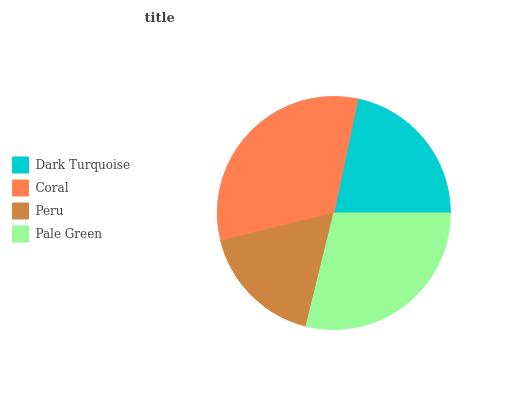Is Peru the minimum?
Answer yes or no. Yes. Is Coral the maximum?
Answer yes or no. Yes. Is Coral the minimum?
Answer yes or no. No. Is Peru the maximum?
Answer yes or no. No. Is Coral greater than Peru?
Answer yes or no. Yes. Is Peru less than Coral?
Answer yes or no. Yes. Is Peru greater than Coral?
Answer yes or no. No. Is Coral less than Peru?
Answer yes or no. No. Is Pale Green the high median?
Answer yes or no. Yes. Is Dark Turquoise the low median?
Answer yes or no. Yes. Is Peru the high median?
Answer yes or no. No. Is Pale Green the low median?
Answer yes or no. No. 